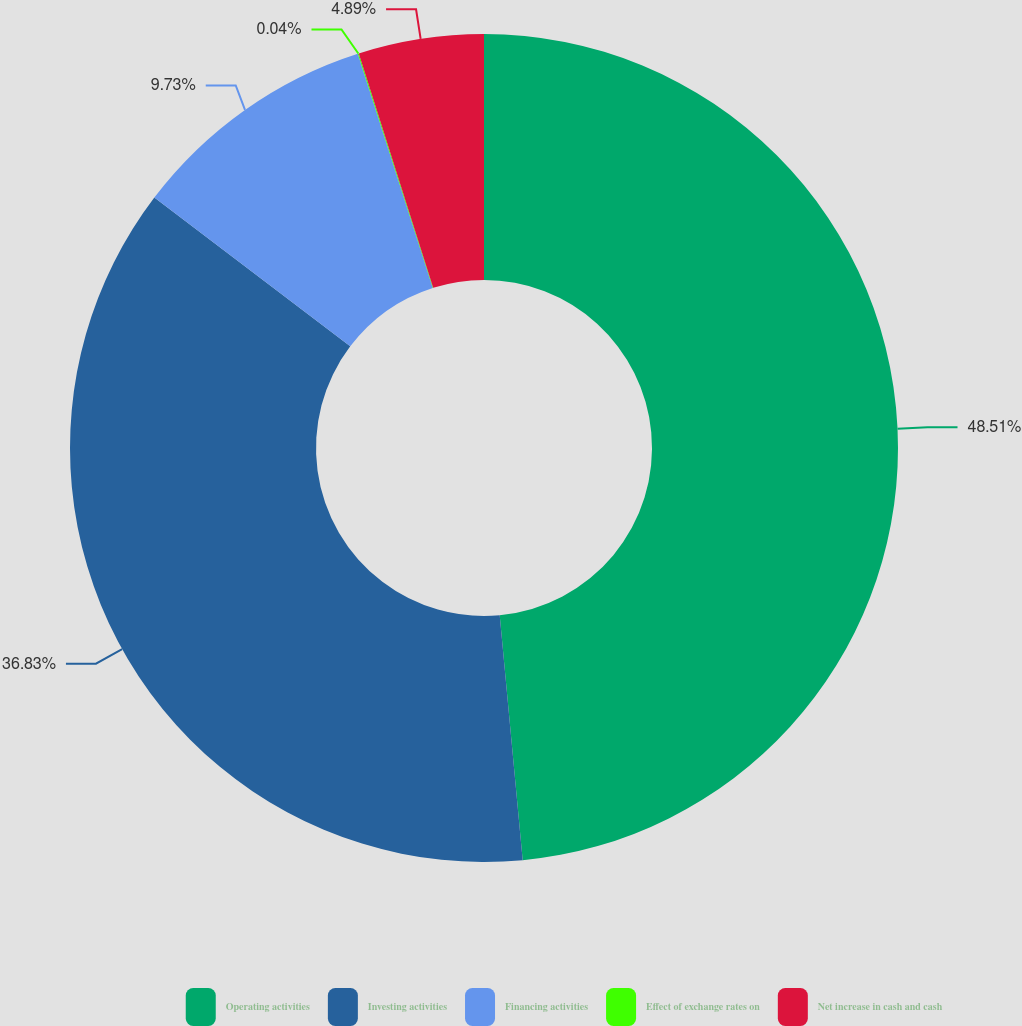Convert chart to OTSL. <chart><loc_0><loc_0><loc_500><loc_500><pie_chart><fcel>Operating activities<fcel>Investing activities<fcel>Financing activities<fcel>Effect of exchange rates on<fcel>Net increase in cash and cash<nl><fcel>48.51%<fcel>36.83%<fcel>9.73%<fcel>0.04%<fcel>4.89%<nl></chart> 